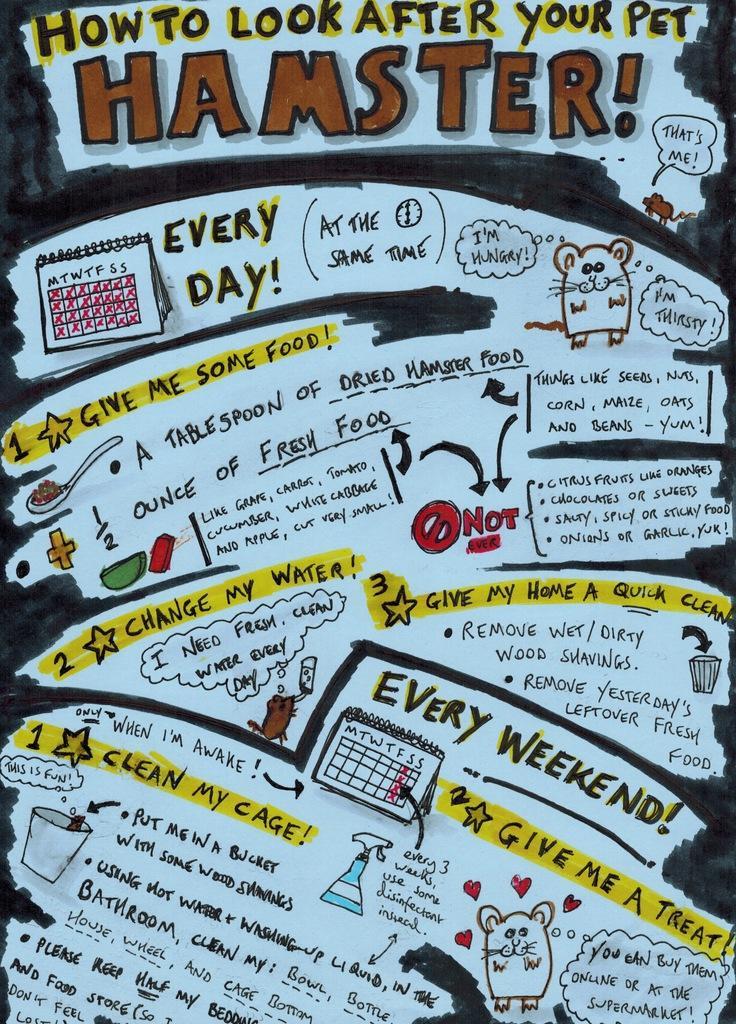Can you describe this image briefly? In this image we can see a drawing of some animals,some objects, calendar, some number and some text. 